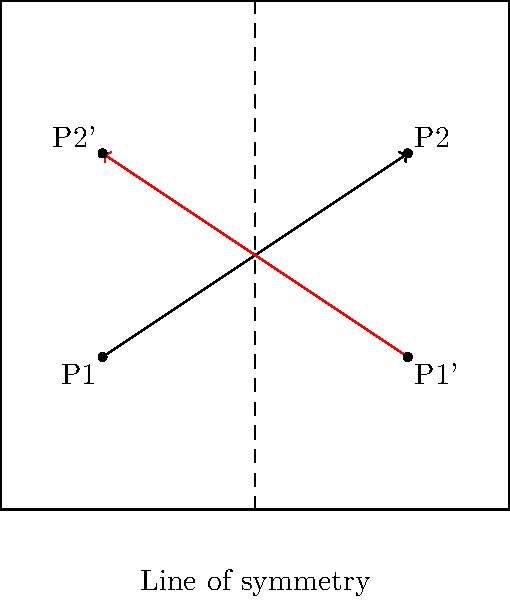In a memorable match, you executed a perfect cross-court shot from point P1 to P2. If this trajectory were to be reflected across the center line of the court (shown as a dashed line), what would be the coordinates of the endpoint (P2') of the reflected shot? To solve this problem, we need to apply the concept of reflection across a line of symmetry. Here's a step-by-step approach:

1) First, identify the line of symmetry. In this case, it's the center line of the court, represented by the equation $x = 5$.

2) The original shot goes from P1(2,3) to P2(8,7).

3) To reflect a point across the line $x = 5$, we use the formula:
   $x' = 10 - x$
   $y' = y$

4) For P2(8,7):
   $x' = 10 - 8 = 2$
   $y' = 7$

5) Therefore, the reflected endpoint P2' has coordinates (2,7).

This reflection essentially "flips" the shot horizontally across the center line while maintaining the same vertical position.
Answer: (2,7) 